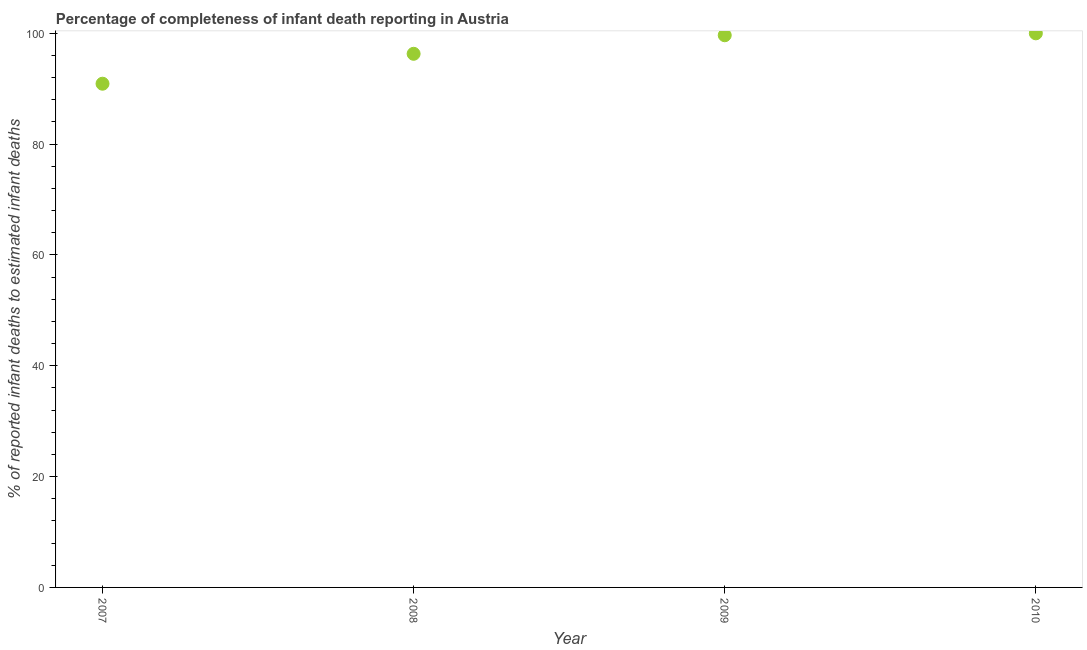What is the completeness of infant death reporting in 2007?
Keep it short and to the point. 90.91. Across all years, what is the maximum completeness of infant death reporting?
Offer a terse response. 100. Across all years, what is the minimum completeness of infant death reporting?
Keep it short and to the point. 90.91. In which year was the completeness of infant death reporting maximum?
Provide a short and direct response. 2010. In which year was the completeness of infant death reporting minimum?
Make the answer very short. 2007. What is the sum of the completeness of infant death reporting?
Your response must be concise. 386.87. What is the difference between the completeness of infant death reporting in 2009 and 2010?
Your answer should be very brief. -0.34. What is the average completeness of infant death reporting per year?
Keep it short and to the point. 96.72. What is the median completeness of infant death reporting?
Give a very brief answer. 97.98. In how many years, is the completeness of infant death reporting greater than 88 %?
Your answer should be very brief. 4. Do a majority of the years between 2010 and 2008 (inclusive) have completeness of infant death reporting greater than 24 %?
Ensure brevity in your answer.  No. What is the ratio of the completeness of infant death reporting in 2007 to that in 2010?
Provide a succinct answer. 0.91. Is the completeness of infant death reporting in 2008 less than that in 2009?
Your answer should be compact. Yes. What is the difference between the highest and the second highest completeness of infant death reporting?
Your answer should be compact. 0.34. What is the difference between the highest and the lowest completeness of infant death reporting?
Your answer should be very brief. 9.09. In how many years, is the completeness of infant death reporting greater than the average completeness of infant death reporting taken over all years?
Provide a short and direct response. 2. How many dotlines are there?
Your answer should be compact. 1. What is the difference between two consecutive major ticks on the Y-axis?
Ensure brevity in your answer.  20. Are the values on the major ticks of Y-axis written in scientific E-notation?
Provide a succinct answer. No. What is the title of the graph?
Offer a very short reply. Percentage of completeness of infant death reporting in Austria. What is the label or title of the X-axis?
Ensure brevity in your answer.  Year. What is the label or title of the Y-axis?
Provide a succinct answer. % of reported infant deaths to estimated infant deaths. What is the % of reported infant deaths to estimated infant deaths in 2007?
Your answer should be compact. 90.91. What is the % of reported infant deaths to estimated infant deaths in 2008?
Your answer should be compact. 96.31. What is the % of reported infant deaths to estimated infant deaths in 2009?
Your answer should be very brief. 99.66. What is the difference between the % of reported infant deaths to estimated infant deaths in 2007 and 2008?
Keep it short and to the point. -5.4. What is the difference between the % of reported infant deaths to estimated infant deaths in 2007 and 2009?
Your answer should be very brief. -8.75. What is the difference between the % of reported infant deaths to estimated infant deaths in 2007 and 2010?
Ensure brevity in your answer.  -9.09. What is the difference between the % of reported infant deaths to estimated infant deaths in 2008 and 2009?
Your answer should be compact. -3.35. What is the difference between the % of reported infant deaths to estimated infant deaths in 2008 and 2010?
Your response must be concise. -3.69. What is the difference between the % of reported infant deaths to estimated infant deaths in 2009 and 2010?
Offer a very short reply. -0.34. What is the ratio of the % of reported infant deaths to estimated infant deaths in 2007 to that in 2008?
Provide a short and direct response. 0.94. What is the ratio of the % of reported infant deaths to estimated infant deaths in 2007 to that in 2009?
Your response must be concise. 0.91. What is the ratio of the % of reported infant deaths to estimated infant deaths in 2007 to that in 2010?
Keep it short and to the point. 0.91. What is the ratio of the % of reported infant deaths to estimated infant deaths in 2008 to that in 2009?
Offer a very short reply. 0.97. What is the ratio of the % of reported infant deaths to estimated infant deaths in 2009 to that in 2010?
Your answer should be compact. 1. 